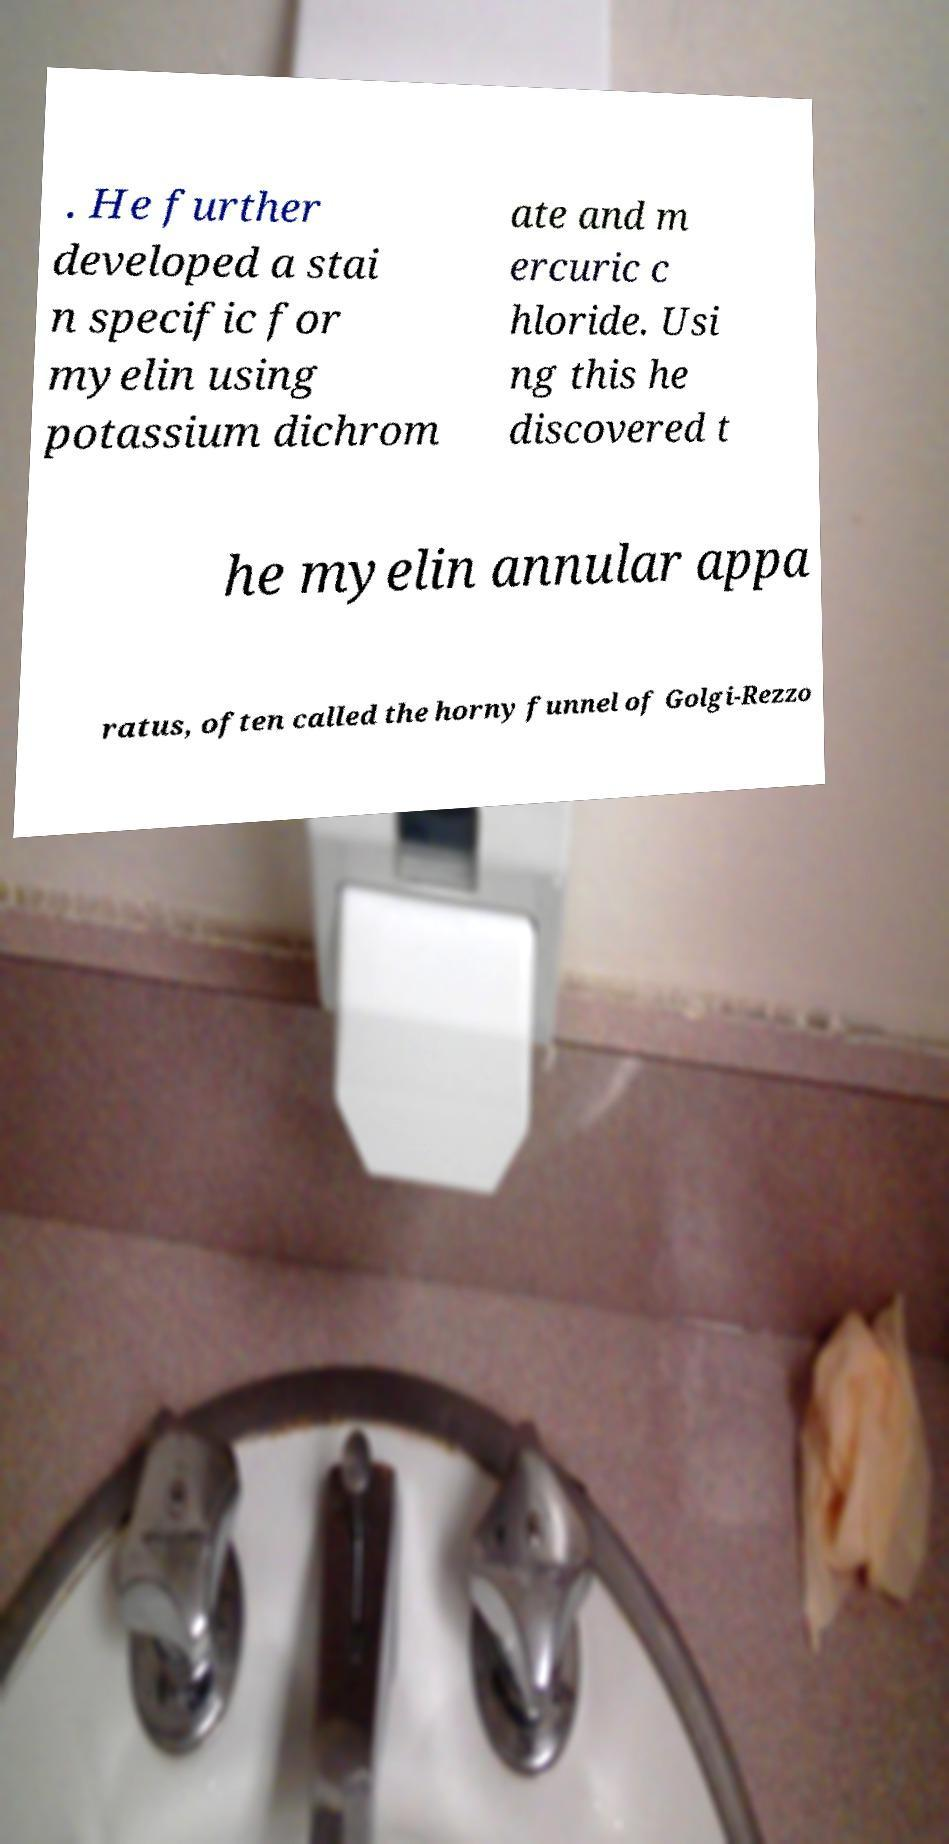There's text embedded in this image that I need extracted. Can you transcribe it verbatim? . He further developed a stai n specific for myelin using potassium dichrom ate and m ercuric c hloride. Usi ng this he discovered t he myelin annular appa ratus, often called the horny funnel of Golgi-Rezzo 